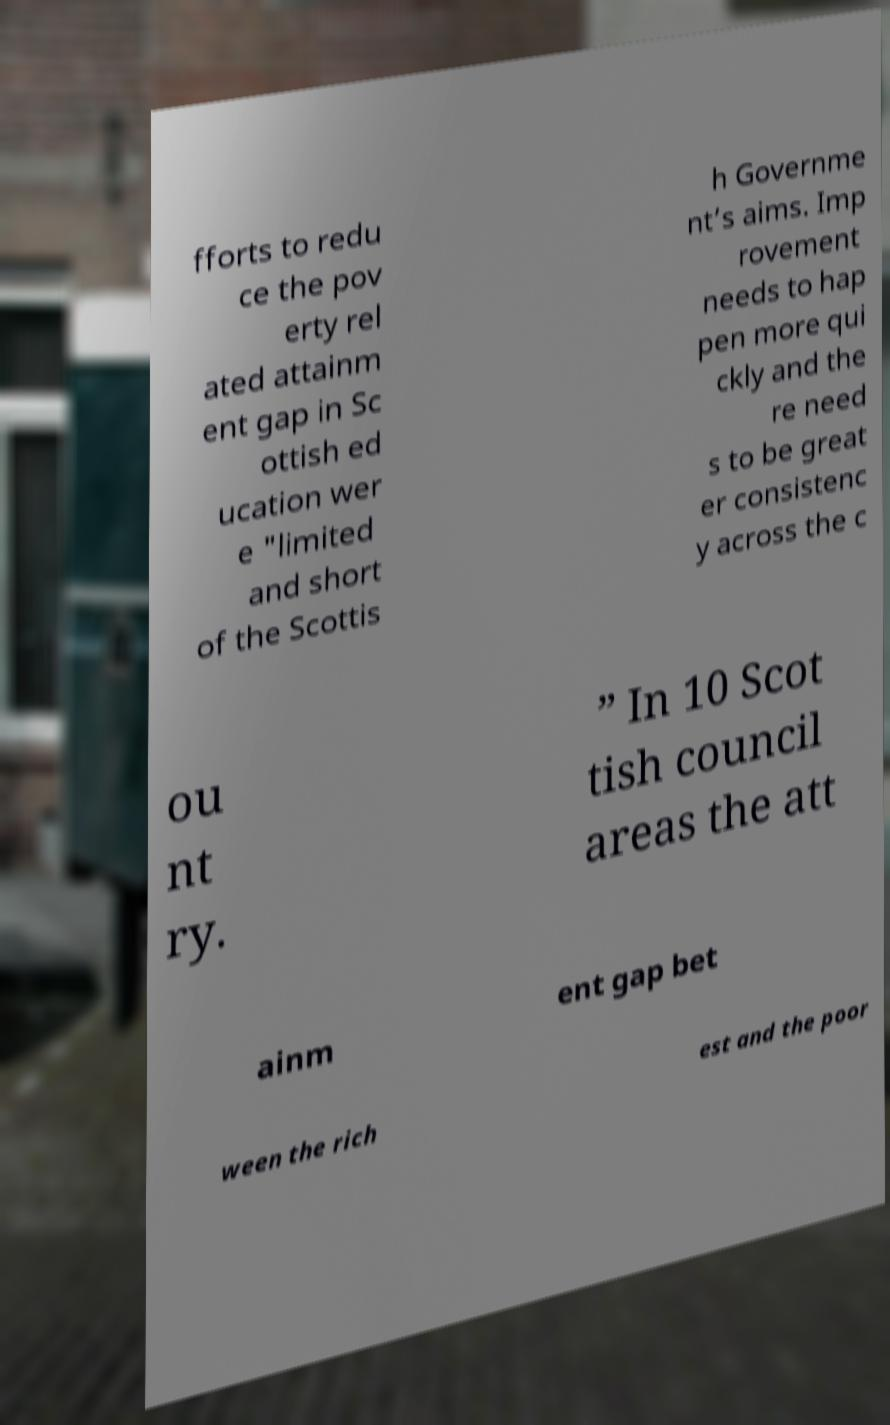What messages or text are displayed in this image? I need them in a readable, typed format. fforts to redu ce the pov erty rel ated attainm ent gap in Sc ottish ed ucation wer e "limited and short of the Scottis h Governme nt’s aims. Imp rovement needs to hap pen more qui ckly and the re need s to be great er consistenc y across the c ou nt ry. ” In 10 Scot tish council areas the att ainm ent gap bet ween the rich est and the poor 